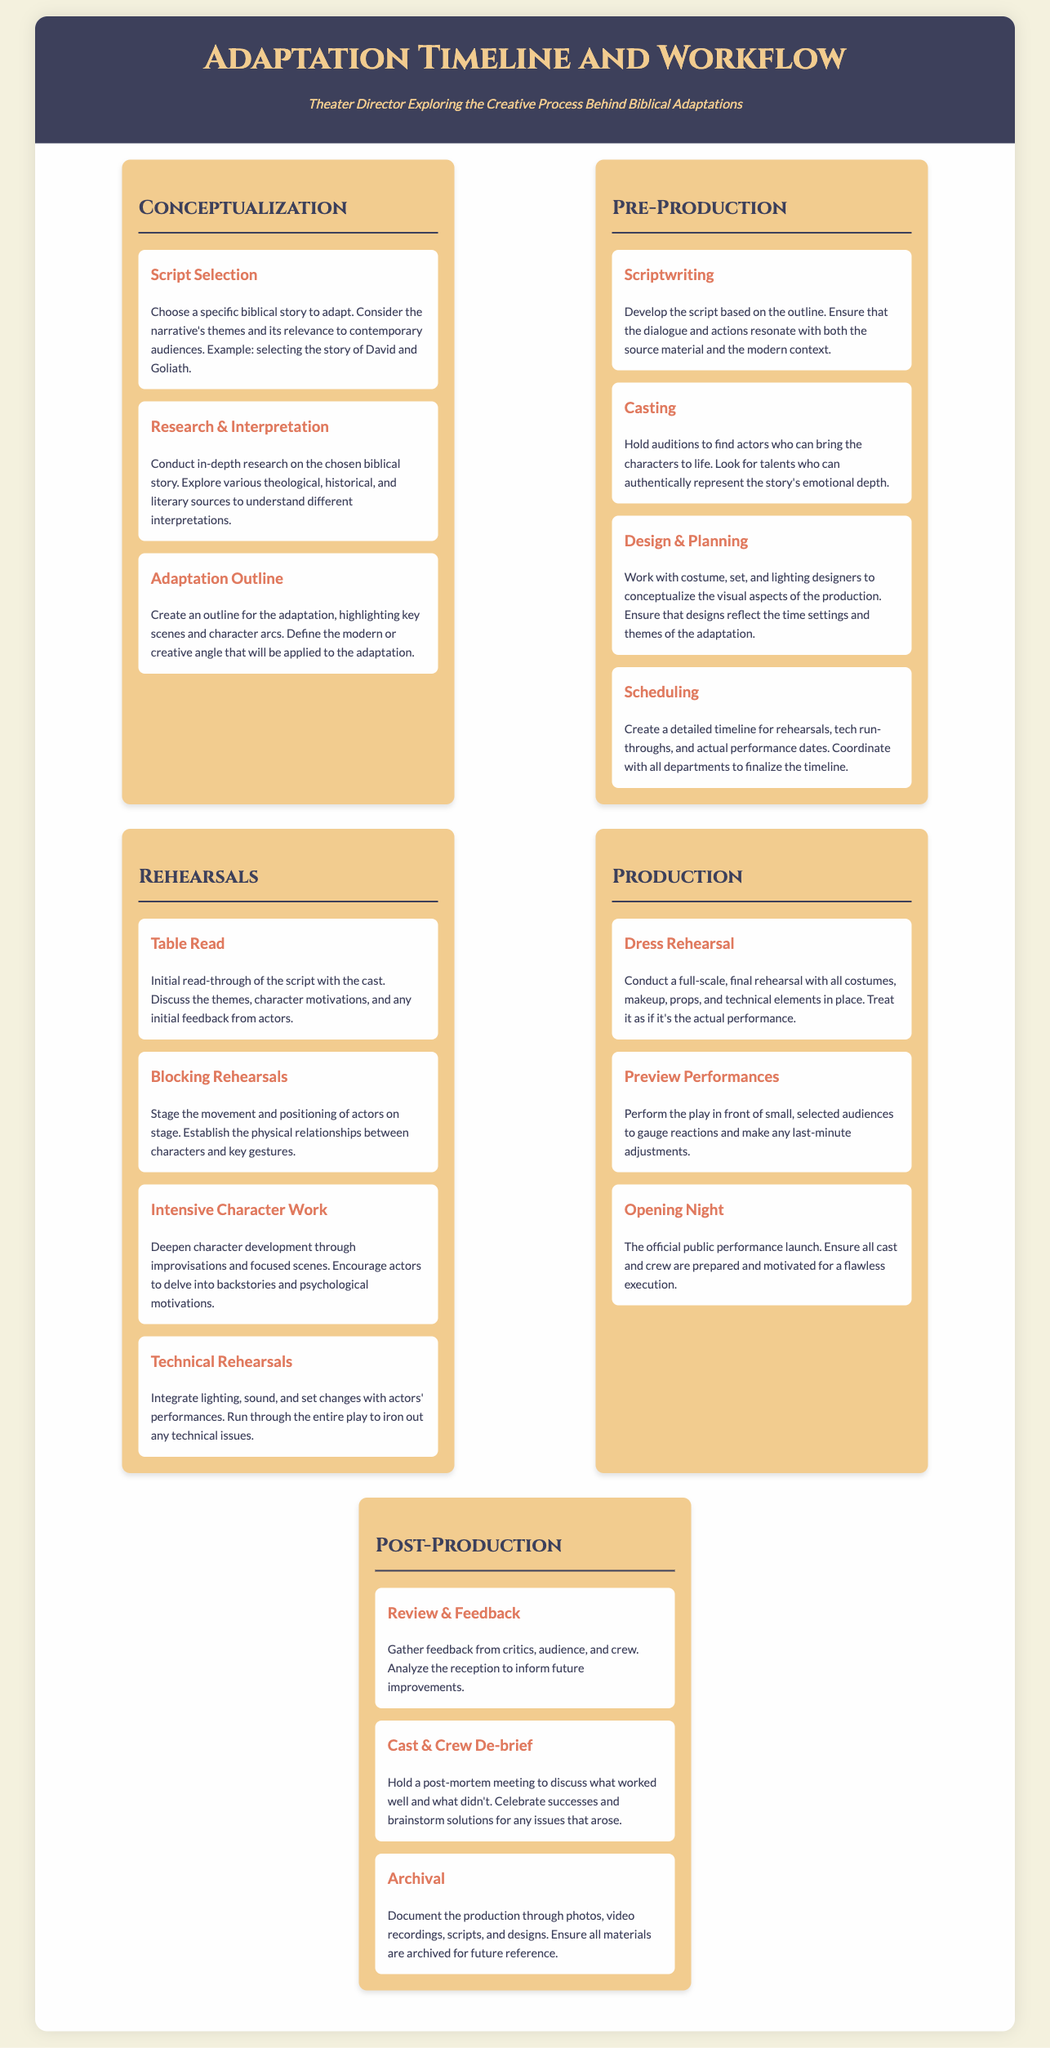what is the first step in the adaptation process? The first step in the adaptation process is selecting a specific biblical story to adapt.
Answer: Script Selection what does the design phase involve? The design phase involves working with costume, set, and lighting designers to conceptualize the visual aspects of the production.
Answer: Design & Planning how many sections are in the timeline? The timeline is divided into four sections: Conceptualization, Pre-Production, Rehearsals, Production, and Post-Production.
Answer: Five what type of rehearsal is conducted as a final full-scale run through? The final rehearsal with all costumes, makeup, props, and technical elements is called a Dress Rehearsal.
Answer: Dress Rehearsal what is done during the Preview Performances? During the Preview Performances, the play is performed in front of small, selected audiences to gauge reactions.
Answer: Gauge reactions what follows after Opening Night? After Opening Night, the next step is to gather feedback from critics, audience, and crew.
Answer: Review & Feedback what is emphasized in the Casting step? In the Casting step, it is emphasized to find actors who can authentically represent the story's emotional depth.
Answer: Emotional depth how often should a post-mortem meeting occur? A post-mortem meeting is held after the production to discuss what worked well and what didn't.
Answer: After the production what type of adaptation is highlighted in the adaptation outline? The adaptation outline highlights key scenes and the modern or creative angle that will be applied to the adaptation.
Answer: Modern or creative angle 